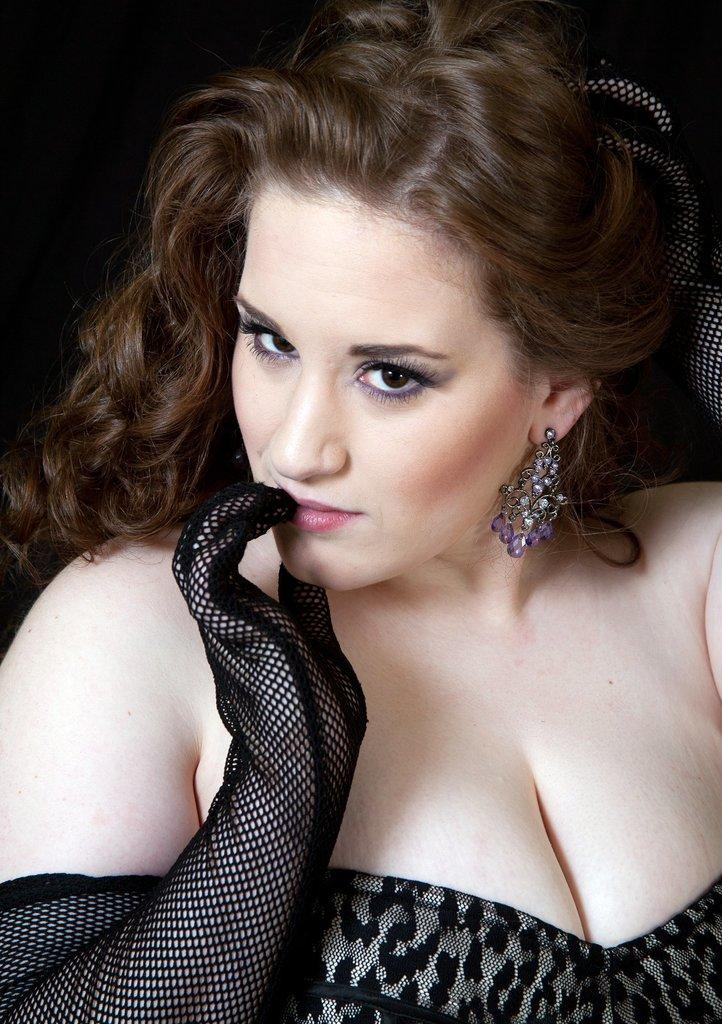Who is present in the image? There is a woman in the image. What is the woman wearing? The woman is wearing clothes and earrings. Can you describe the background of the image? The background of the image is blurred. What type of vest can be seen on the moon in the image? There is no moon or vest present in the image. 